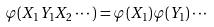Convert formula to latex. <formula><loc_0><loc_0><loc_500><loc_500>\varphi ( X _ { 1 } Y _ { 1 } X _ { 2 } \cdots ) = \varphi ( X _ { 1 } ) \varphi ( Y _ { 1 } ) \cdots</formula> 